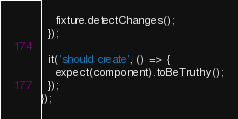Convert code to text. <code><loc_0><loc_0><loc_500><loc_500><_TypeScript_>    fixture.detectChanges();
  });

  it('should create', () => {
    expect(component).toBeTruthy();
  });
});
</code> 